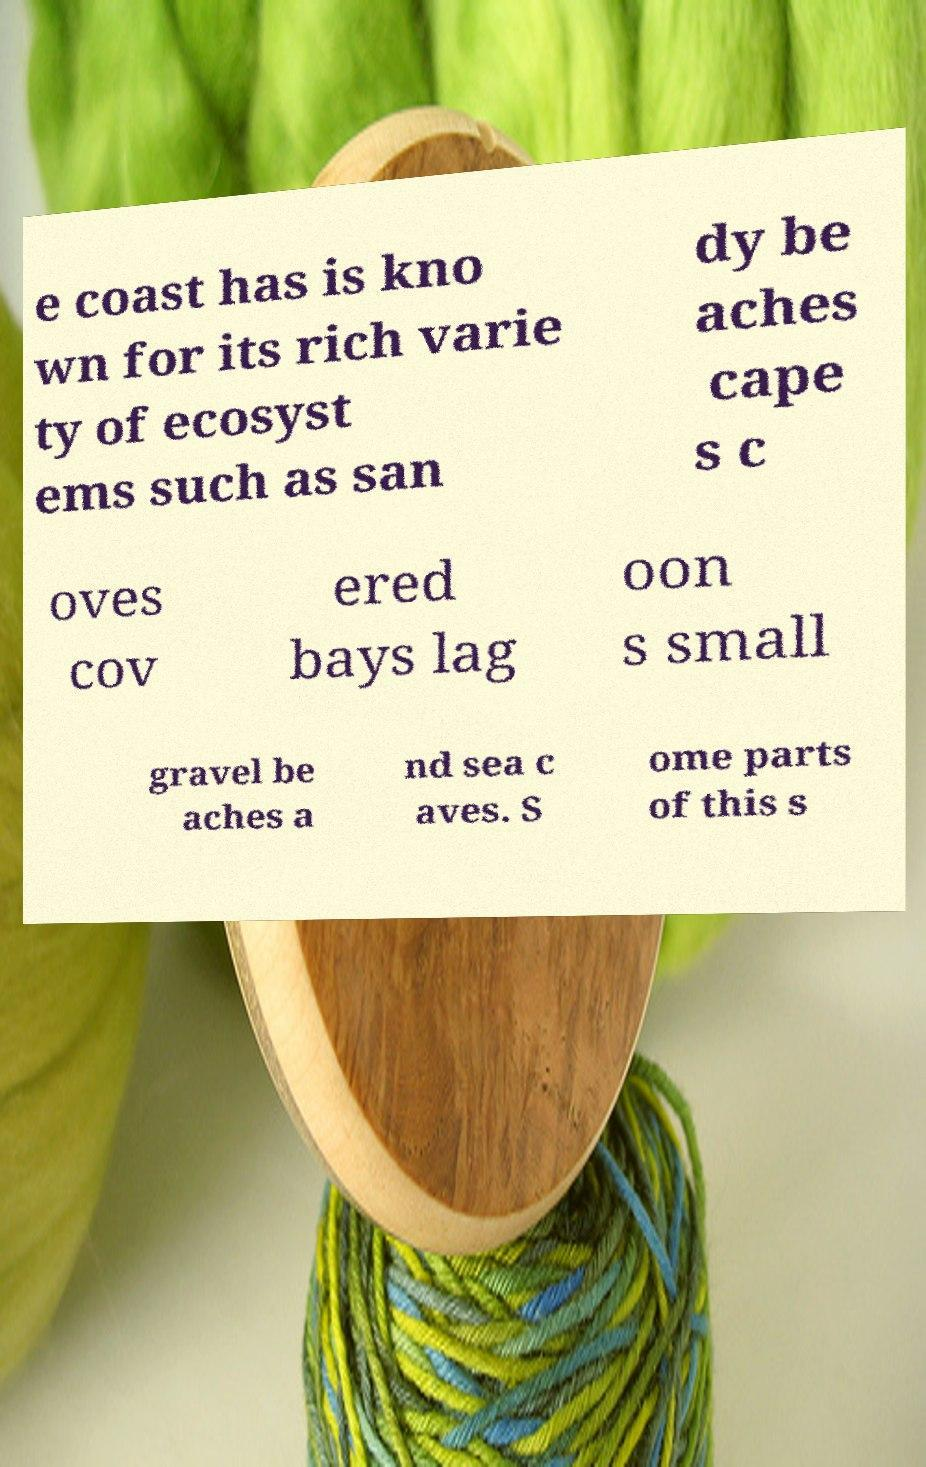Please read and relay the text visible in this image. What does it say? e coast has is kno wn for its rich varie ty of ecosyst ems such as san dy be aches cape s c oves cov ered bays lag oon s small gravel be aches a nd sea c aves. S ome parts of this s 